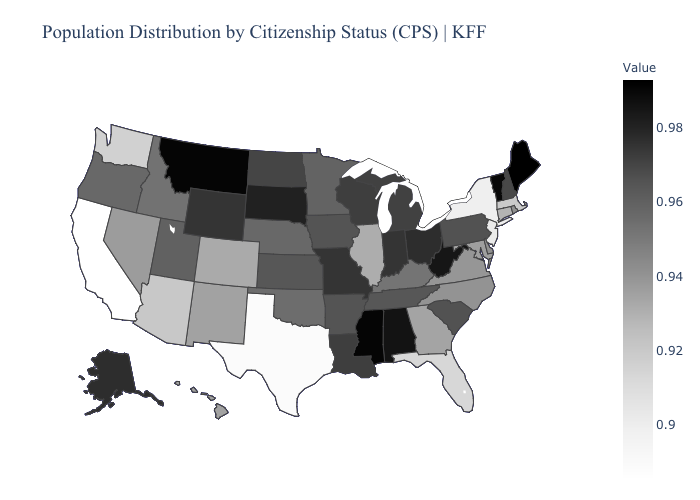Which states have the highest value in the USA?
Keep it brief. Maine. Among the states that border California , which have the lowest value?
Be succinct. Arizona. Among the states that border New Mexico , which have the lowest value?
Give a very brief answer. Texas. Does Texas have the lowest value in the South?
Answer briefly. Yes. 